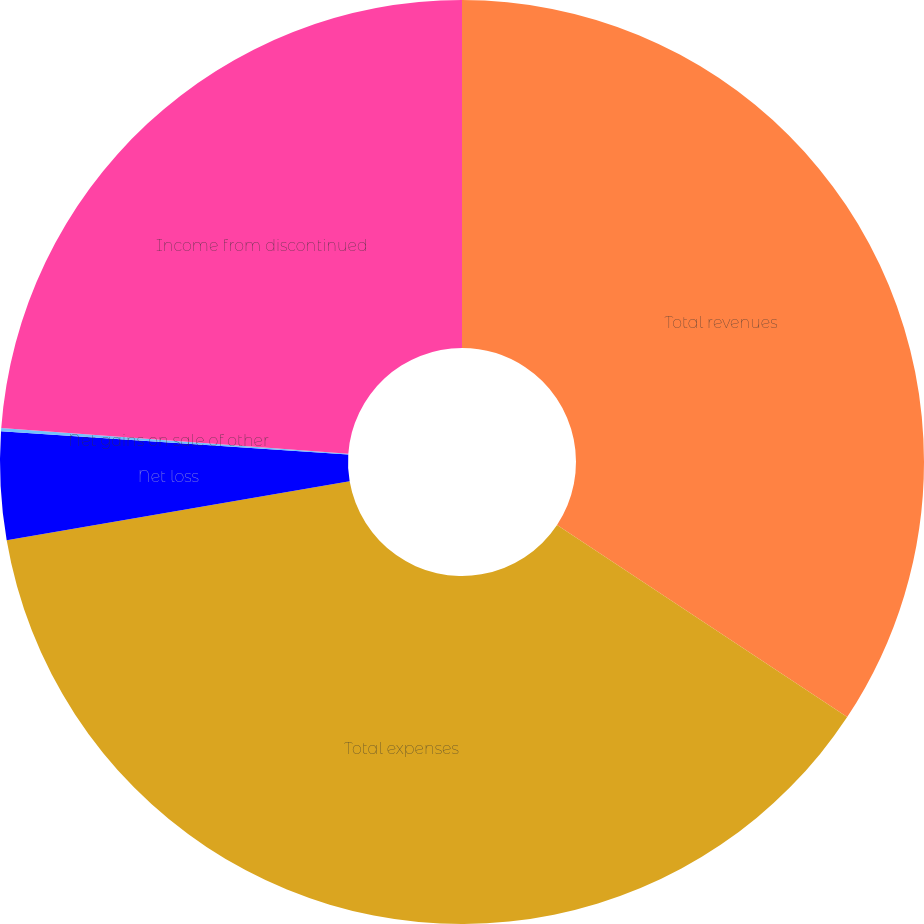<chart> <loc_0><loc_0><loc_500><loc_500><pie_chart><fcel>Total revenues<fcel>Total expenses<fcel>Net loss<fcel>Net gains on sale of other<fcel>Income from discontinued<nl><fcel>34.31%<fcel>37.98%<fcel>3.77%<fcel>0.11%<fcel>23.83%<nl></chart> 